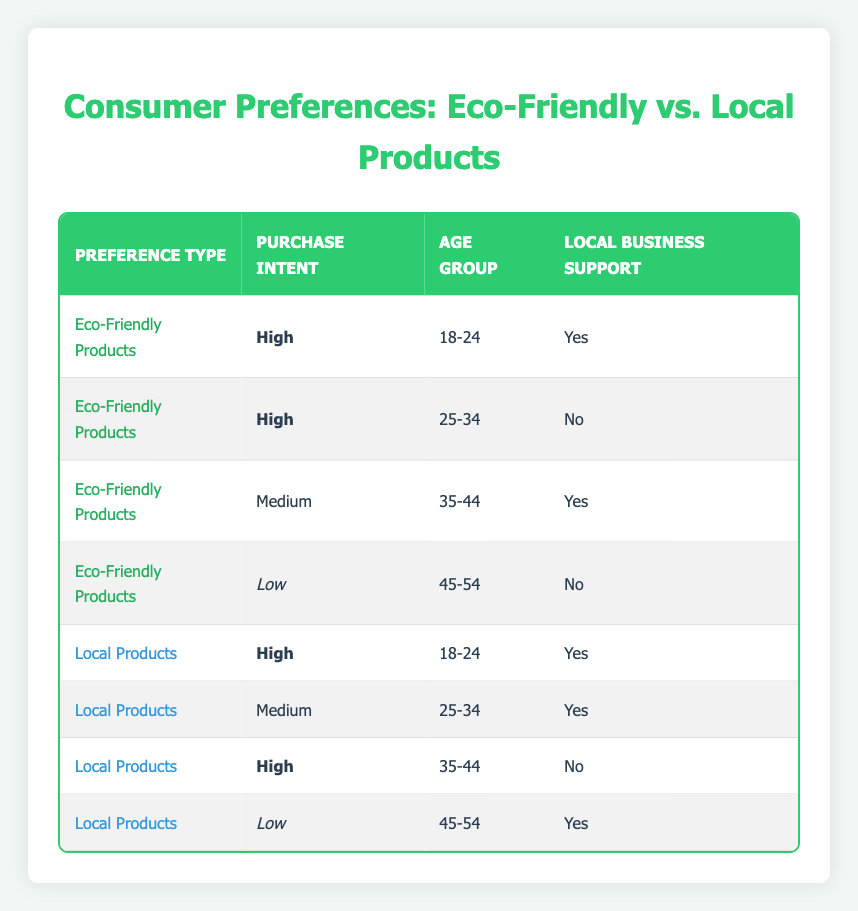What is the purchase intent of consumers for eco-friendly products in the age group 18-24? In the table, we look at the row where the Preference Type is "Eco-Friendly Products" and the Age Group is "18-24." The corresponding Purchase Intent in that row shows "High."
Answer: High How many age groups show a high purchase intent for local products? By examining the table, there are two entries for Local Products with a high purchase intent: one for the 18-24 age group and another for the 35-44 age group. Therefore, the count is 2.
Answer: 2 Is there a local business support for consumers who prefer eco-friendly products with low purchase intent? We find the entry for "Eco-Friendly Products" where Purchase Intent is "Low." The corresponding row indicates that the Local Business Support is "No." Thus, the answer is negative.
Answer: No What is the total number of respondents from the age group 45-54 who support local businesses? We check the rows for age group 45-54. There are two entries: one for "Eco-Friendly Products" with "No" support and the other for "Local Products" with "Yes" support. Hence, there is a total of one respondent who supports local businesses.
Answer: 1 Which preference type has a higher count of medium purchase intent across age groups, eco-friendly products or local products? We analyze the table to locate entries with "Medium" purchase intent. Eco-friendly products show one (from the 35-44 age group), while local products show one (from the 25-34 age group). Hence, both have the same count.
Answer: Same count How many consumers aged 25-34 support local businesses while having medium purchase intent? Referring to the table, for Local Products, the 25-34 age group is associated with "Yes" in Local Business Support. Therefore, this group supports local businesses as specified.
Answer: 1 Are there any preferences for eco-friendly products among those aged 45-54 who support local businesses? We review the entries for the age group 45-54 in the table. The row for "Eco-Friendly Products" shows "No" for Local Business Support. Thus, there are indeed no preferences in this category.
Answer: No What is the ratio of high purchase intent for eco-friendly products to local products? From the table, there are two rows for each category with high purchase intent. Eco-Friendly Products have two entries (18-24 and 25-34), and Local Products also have two entries (18-24 and 35-44). Therefore, the ratio of high purchase intent is 2:2, which reduces to 1:1.
Answer: 1:1 